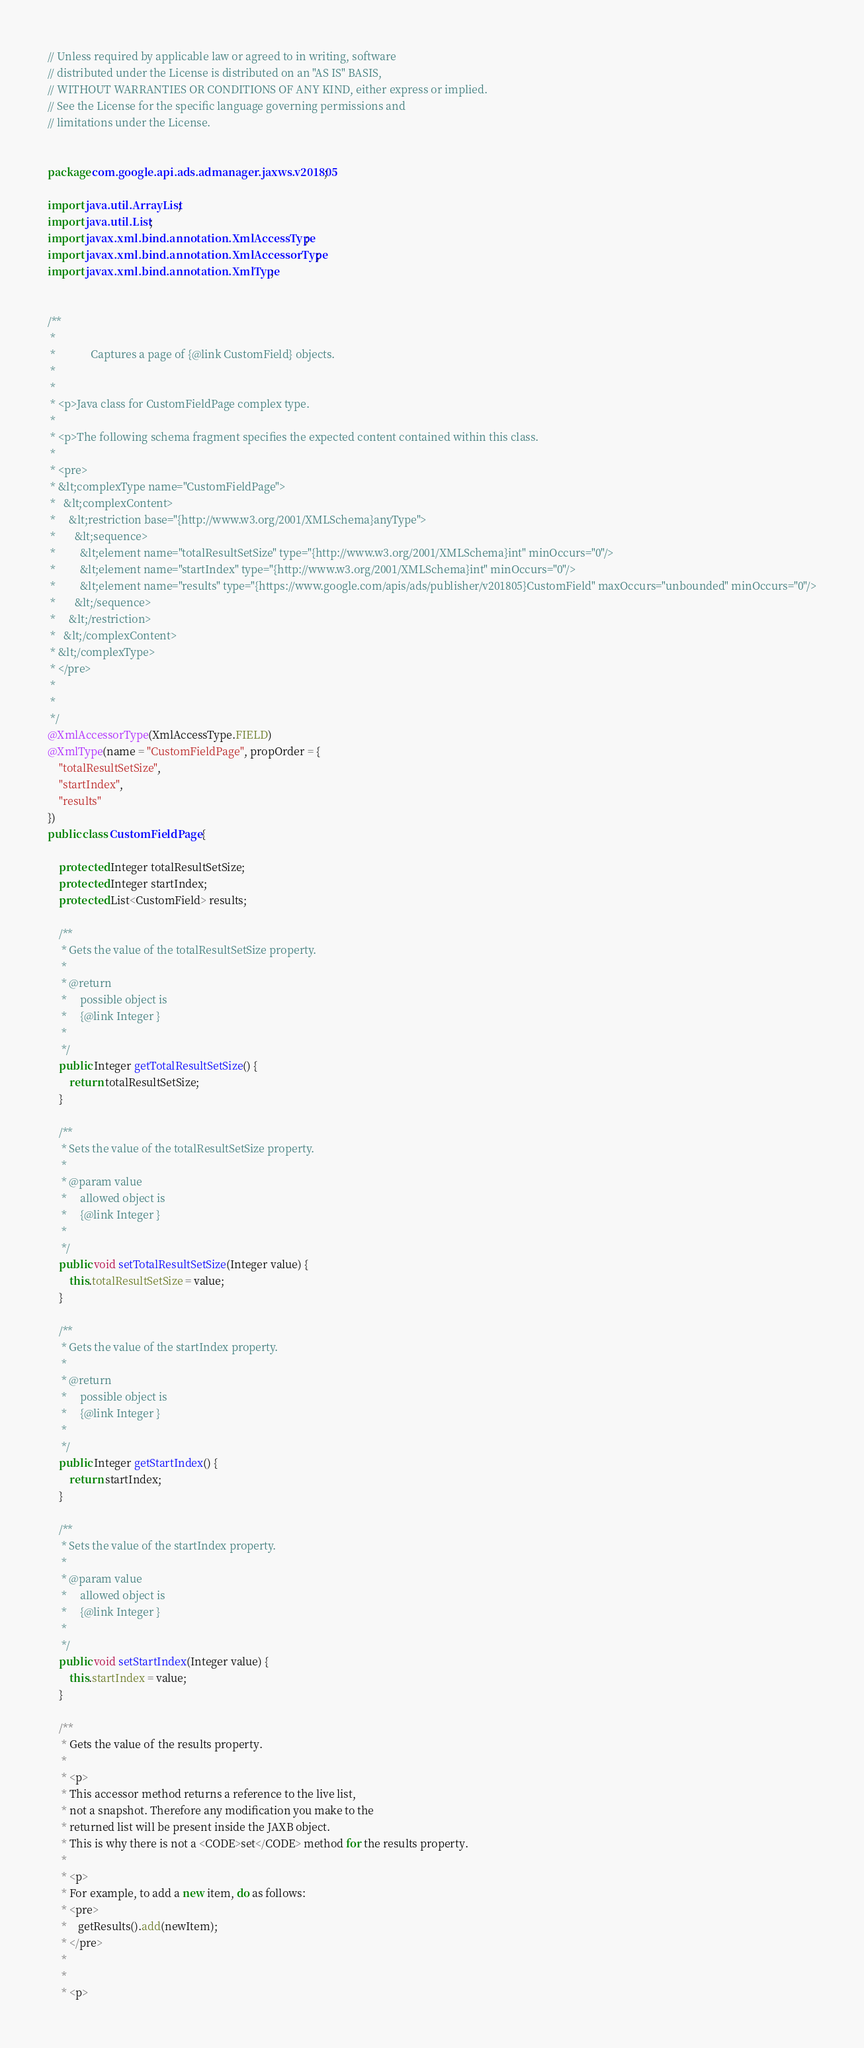Convert code to text. <code><loc_0><loc_0><loc_500><loc_500><_Java_>// Unless required by applicable law or agreed to in writing, software
// distributed under the License is distributed on an "AS IS" BASIS,
// WITHOUT WARRANTIES OR CONDITIONS OF ANY KIND, either express or implied.
// See the License for the specific language governing permissions and
// limitations under the License.


package com.google.api.ads.admanager.jaxws.v201805;

import java.util.ArrayList;
import java.util.List;
import javax.xml.bind.annotation.XmlAccessType;
import javax.xml.bind.annotation.XmlAccessorType;
import javax.xml.bind.annotation.XmlType;


/**
 * 
 *             Captures a page of {@link CustomField} objects.
 *           
 * 
 * <p>Java class for CustomFieldPage complex type.
 * 
 * <p>The following schema fragment specifies the expected content contained within this class.
 * 
 * <pre>
 * &lt;complexType name="CustomFieldPage">
 *   &lt;complexContent>
 *     &lt;restriction base="{http://www.w3.org/2001/XMLSchema}anyType">
 *       &lt;sequence>
 *         &lt;element name="totalResultSetSize" type="{http://www.w3.org/2001/XMLSchema}int" minOccurs="0"/>
 *         &lt;element name="startIndex" type="{http://www.w3.org/2001/XMLSchema}int" minOccurs="0"/>
 *         &lt;element name="results" type="{https://www.google.com/apis/ads/publisher/v201805}CustomField" maxOccurs="unbounded" minOccurs="0"/>
 *       &lt;/sequence>
 *     &lt;/restriction>
 *   &lt;/complexContent>
 * &lt;/complexType>
 * </pre>
 * 
 * 
 */
@XmlAccessorType(XmlAccessType.FIELD)
@XmlType(name = "CustomFieldPage", propOrder = {
    "totalResultSetSize",
    "startIndex",
    "results"
})
public class CustomFieldPage {

    protected Integer totalResultSetSize;
    protected Integer startIndex;
    protected List<CustomField> results;

    /**
     * Gets the value of the totalResultSetSize property.
     * 
     * @return
     *     possible object is
     *     {@link Integer }
     *     
     */
    public Integer getTotalResultSetSize() {
        return totalResultSetSize;
    }

    /**
     * Sets the value of the totalResultSetSize property.
     * 
     * @param value
     *     allowed object is
     *     {@link Integer }
     *     
     */
    public void setTotalResultSetSize(Integer value) {
        this.totalResultSetSize = value;
    }

    /**
     * Gets the value of the startIndex property.
     * 
     * @return
     *     possible object is
     *     {@link Integer }
     *     
     */
    public Integer getStartIndex() {
        return startIndex;
    }

    /**
     * Sets the value of the startIndex property.
     * 
     * @param value
     *     allowed object is
     *     {@link Integer }
     *     
     */
    public void setStartIndex(Integer value) {
        this.startIndex = value;
    }

    /**
     * Gets the value of the results property.
     * 
     * <p>
     * This accessor method returns a reference to the live list,
     * not a snapshot. Therefore any modification you make to the
     * returned list will be present inside the JAXB object.
     * This is why there is not a <CODE>set</CODE> method for the results property.
     * 
     * <p>
     * For example, to add a new item, do as follows:
     * <pre>
     *    getResults().add(newItem);
     * </pre>
     * 
     * 
     * <p></code> 